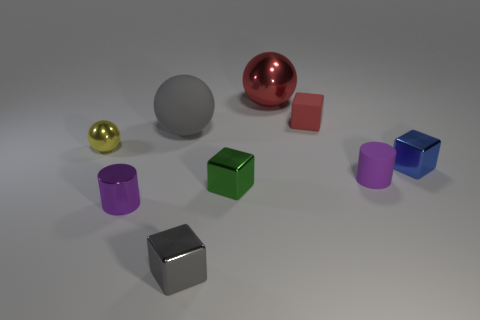Do the gray rubber object and the shiny cube that is in front of the green shiny block have the same size?
Offer a very short reply. No. The matte ball is what color?
Your response must be concise. Gray. There is a small object to the right of the cylinder to the right of the large object that is behind the big rubber sphere; what shape is it?
Offer a very short reply. Cube. There is a small purple cylinder that is to the left of the big red sphere on the right side of the metal cylinder; what is its material?
Provide a succinct answer. Metal. What is the shape of the red thing that is made of the same material as the yellow ball?
Provide a succinct answer. Sphere. Is there any other thing that has the same shape as the tiny yellow thing?
Provide a short and direct response. Yes. There is a small green object; how many large metallic spheres are left of it?
Your answer should be very brief. 0. Is there a big yellow shiny cylinder?
Ensure brevity in your answer.  No. There is a small metal thing that is to the right of the tiny purple cylinder that is on the right side of the gray thing in front of the small shiny sphere; what is its color?
Your answer should be compact. Blue. There is a tiny cube behind the large gray rubber object; are there any red cubes to the right of it?
Your answer should be compact. No. 